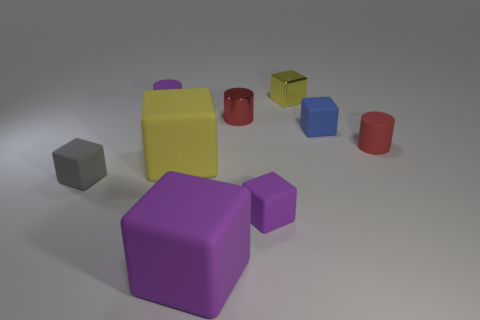Are any big blue matte cylinders visible?
Give a very brief answer. No. What is the material of the red thing that is behind the matte block that is behind the matte cylinder in front of the small purple matte cylinder?
Keep it short and to the point. Metal. Is the shape of the big purple thing the same as the purple object on the right side of the red shiny cylinder?
Your answer should be compact. Yes. What number of other large yellow matte things are the same shape as the yellow matte thing?
Your answer should be compact. 0. What is the shape of the tiny yellow metallic thing?
Your answer should be compact. Cube. What size is the yellow cube behind the cylinder left of the small shiny cylinder?
Your answer should be very brief. Small. What number of objects are either tiny purple things or large brown rubber blocks?
Ensure brevity in your answer.  2. Is the shape of the gray matte object the same as the small red matte object?
Give a very brief answer. No. Is there a small thing that has the same material as the small yellow block?
Give a very brief answer. Yes. There is a small thing in front of the gray matte block; are there any purple matte things in front of it?
Ensure brevity in your answer.  Yes. 